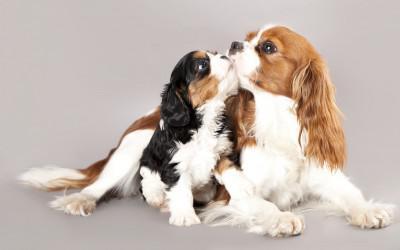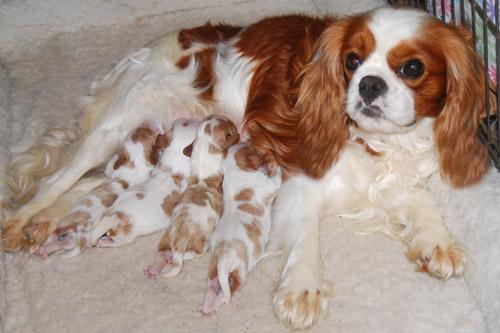The first image is the image on the left, the second image is the image on the right. For the images shown, is this caption "One image shows a nursing mother spaniel with several spotted puppies." true? Answer yes or no. Yes. The first image is the image on the left, the second image is the image on the right. Assess this claim about the two images: "There are 6 total dogs in both images". Correct or not? Answer yes or no. No. 